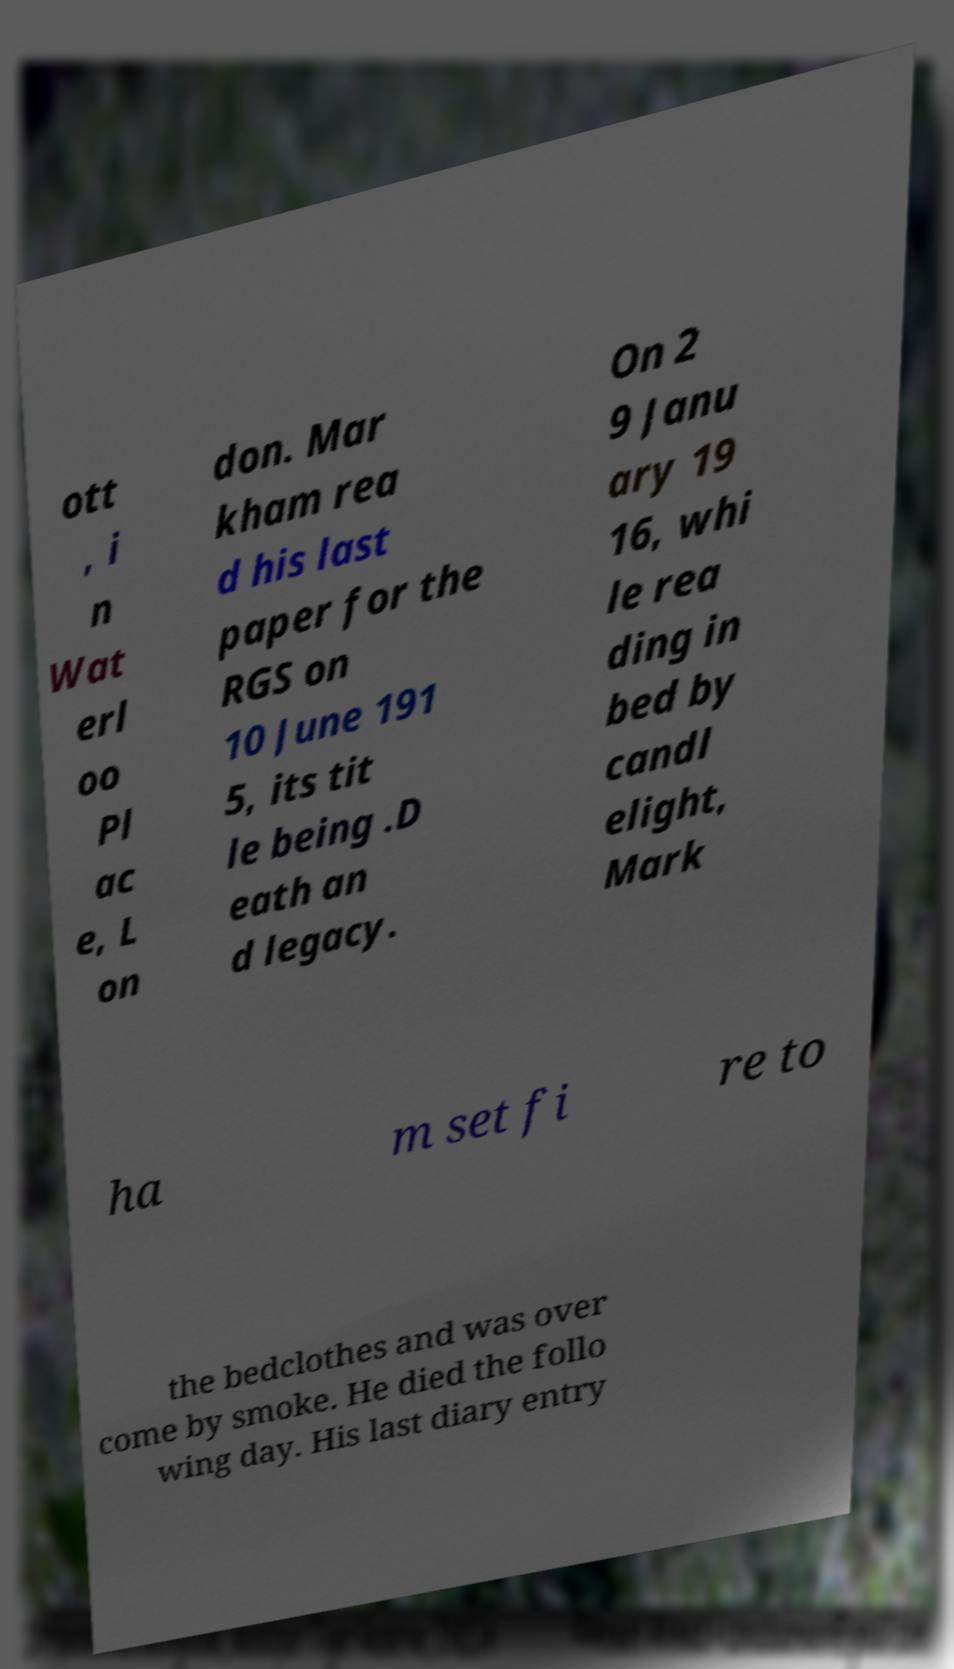For documentation purposes, I need the text within this image transcribed. Could you provide that? ott , i n Wat erl oo Pl ac e, L on don. Mar kham rea d his last paper for the RGS on 10 June 191 5, its tit le being .D eath an d legacy. On 2 9 Janu ary 19 16, whi le rea ding in bed by candl elight, Mark ha m set fi re to the bedclothes and was over come by smoke. He died the follo wing day. His last diary entry 